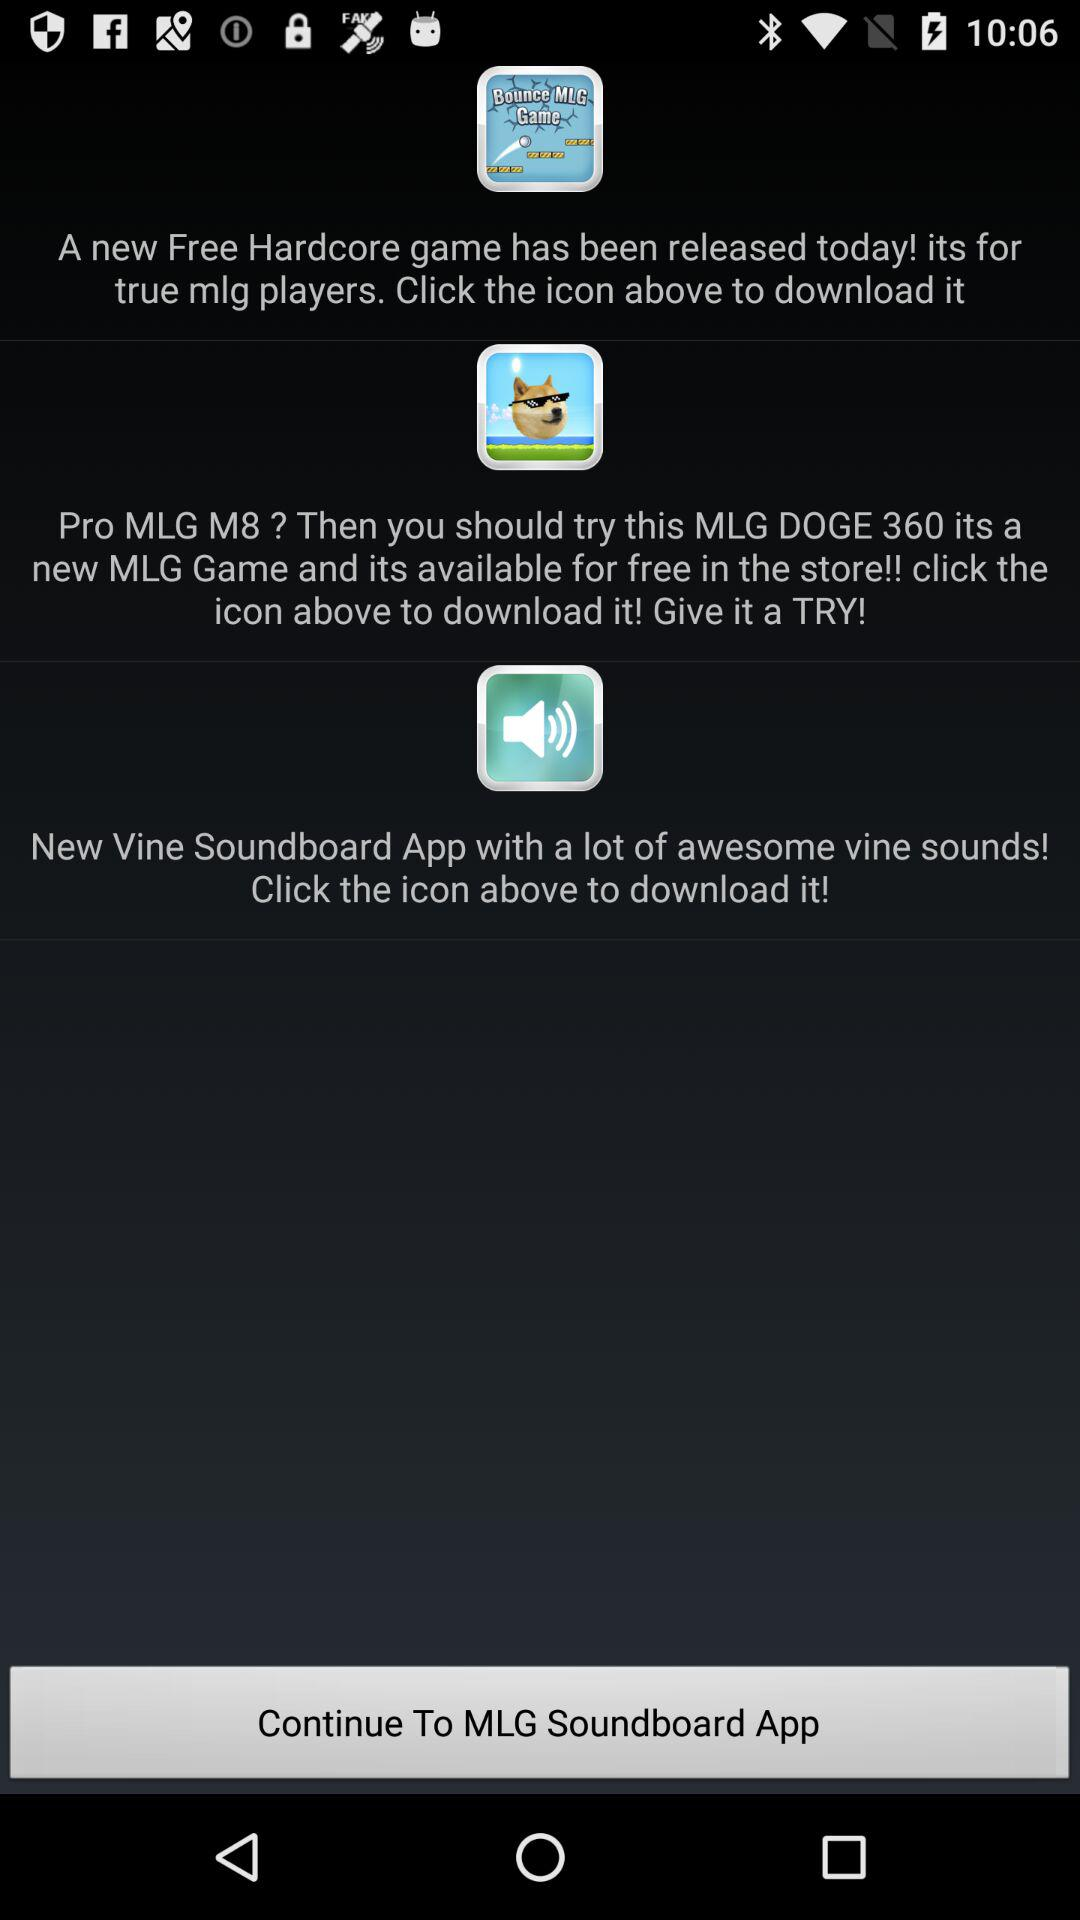What is the application name? The application is "MLG Soundboard". 